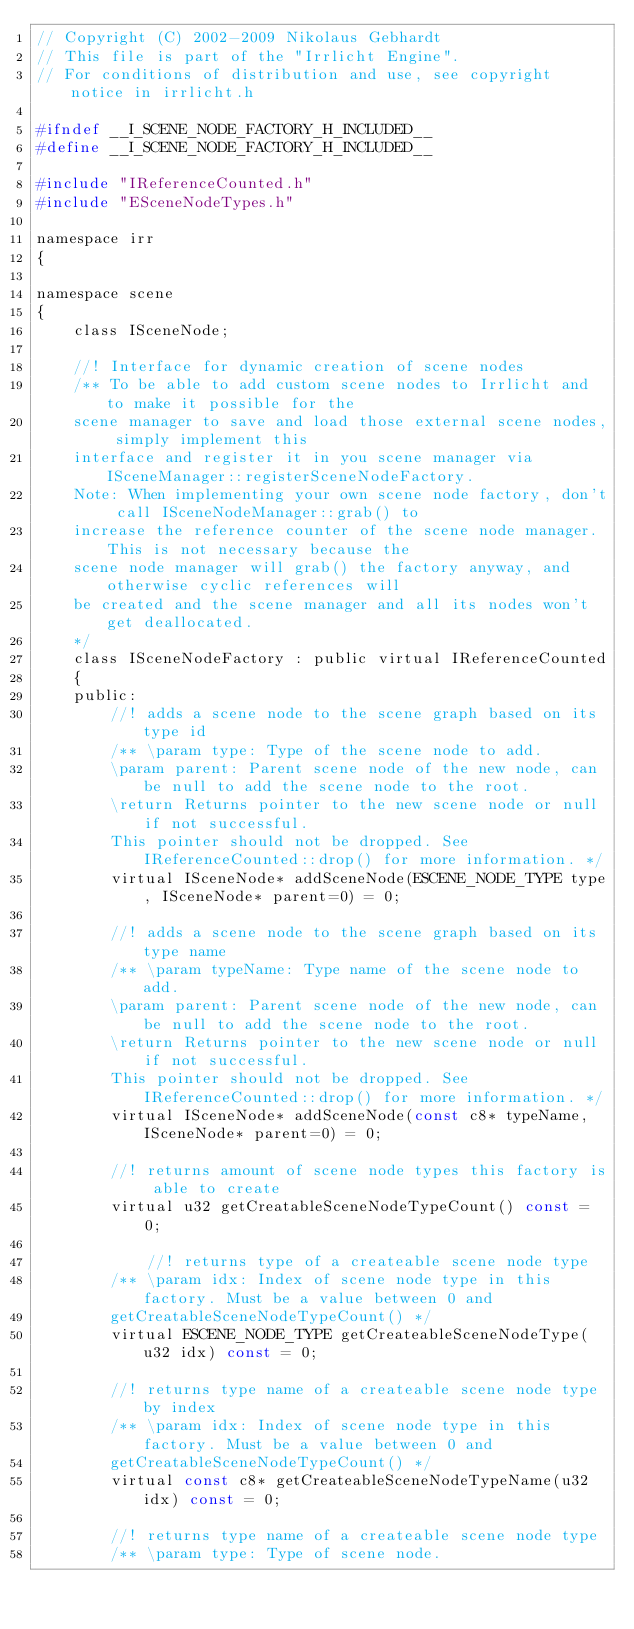Convert code to text. <code><loc_0><loc_0><loc_500><loc_500><_C_>// Copyright (C) 2002-2009 Nikolaus Gebhardt
// This file is part of the "Irrlicht Engine".
// For conditions of distribution and use, see copyright notice in irrlicht.h

#ifndef __I_SCENE_NODE_FACTORY_H_INCLUDED__
#define __I_SCENE_NODE_FACTORY_H_INCLUDED__

#include "IReferenceCounted.h"
#include "ESceneNodeTypes.h"

namespace irr
{

namespace scene
{
	class ISceneNode;

	//! Interface for dynamic creation of scene nodes
	/** To be able to add custom scene nodes to Irrlicht and to make it possible for the
	scene manager to save and load those external scene nodes, simply implement this
	interface and register it in you scene manager via ISceneManager::registerSceneNodeFactory.
	Note: When implementing your own scene node factory, don't call ISceneNodeManager::grab() to
	increase the reference counter of the scene node manager. This is not necessary because the
	scene node manager will grab() the factory anyway, and otherwise cyclic references will
	be created and the scene manager and all its nodes won't get deallocated.
	*/
	class ISceneNodeFactory : public virtual IReferenceCounted
	{
	public:
		//! adds a scene node to the scene graph based on its type id
		/** \param type: Type of the scene node to add.
		\param parent: Parent scene node of the new node, can be null to add the scene node to the root.
		\return Returns pointer to the new scene node or null if not successful.
		This pointer should not be dropped. See IReferenceCounted::drop() for more information. */
		virtual ISceneNode* addSceneNode(ESCENE_NODE_TYPE type, ISceneNode* parent=0) = 0;

		//! adds a scene node to the scene graph based on its type name
		/** \param typeName: Type name of the scene node to add.
		\param parent: Parent scene node of the new node, can be null to add the scene node to the root.
		\return Returns pointer to the new scene node or null if not successful.
		This pointer should not be dropped. See IReferenceCounted::drop() for more information. */
		virtual ISceneNode* addSceneNode(const c8* typeName, ISceneNode* parent=0) = 0;

		//! returns amount of scene node types this factory is able to create
		virtual u32 getCreatableSceneNodeTypeCount() const = 0;

			//! returns type of a createable scene node type
		/** \param idx: Index of scene node type in this factory. Must be a value between 0 and
		getCreatableSceneNodeTypeCount() */
		virtual ESCENE_NODE_TYPE getCreateableSceneNodeType(u32 idx) const = 0;

		//! returns type name of a createable scene node type by index
		/** \param idx: Index of scene node type in this factory. Must be a value between 0 and
		getCreatableSceneNodeTypeCount() */
		virtual const c8* getCreateableSceneNodeTypeName(u32 idx) const = 0;

		//! returns type name of a createable scene node type
		/** \param type: Type of scene node.</code> 